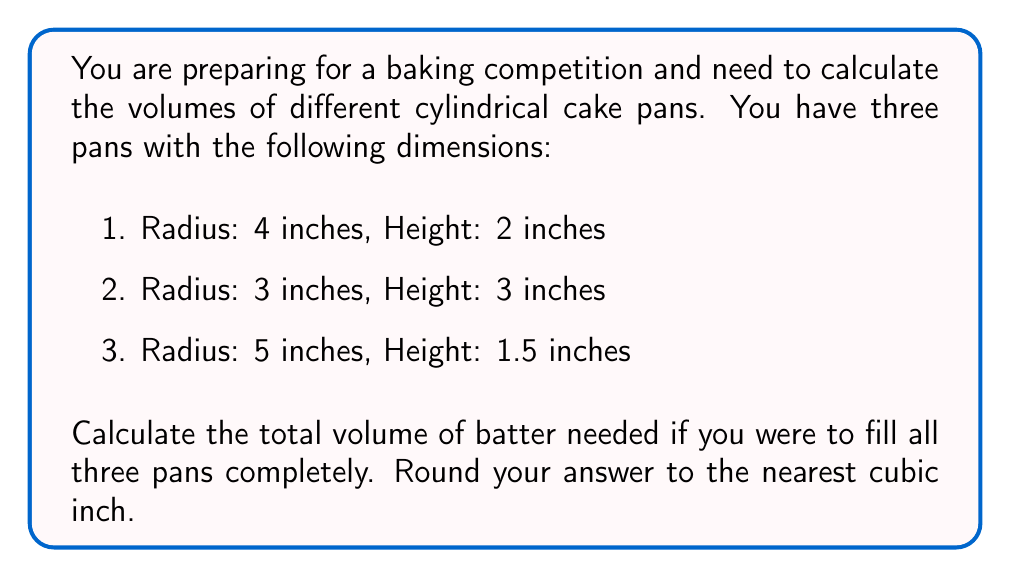Give your solution to this math problem. To solve this problem, we need to follow these steps:

1. Recall the formula for the volume of a cylinder:
   $$V = \pi r^2 h$$
   where $V$ is the volume, $r$ is the radius, and $h$ is the height.

2. Calculate the volume of each pan:

   Pan 1: $r = 4$ inches, $h = 2$ inches
   $$V_1 = \pi (4^2)(2) = 32\pi \approx 100.53 \text{ cubic inches}$$

   Pan 2: $r = 3$ inches, $h = 3$ inches
   $$V_2 = \pi (3^2)(3) = 27\pi \approx 84.82 \text{ cubic inches}$$

   Pan 3: $r = 5$ inches, $h = 1.5$ inches
   $$V_3 = \pi (5^2)(1.5) = 37.5\pi \approx 117.81 \text{ cubic inches}$$

3. Sum up the volumes of all three pans:
   $$V_{total} = V_1 + V_2 + V_3 = 32\pi + 27\pi + 37.5\pi = 96.5\pi \approx 303.16 \text{ cubic inches}$$

4. Round the result to the nearest cubic inch:
   $$V_{total} \approx 303 \text{ cubic inches}$$
Answer: 303 cubic inches 